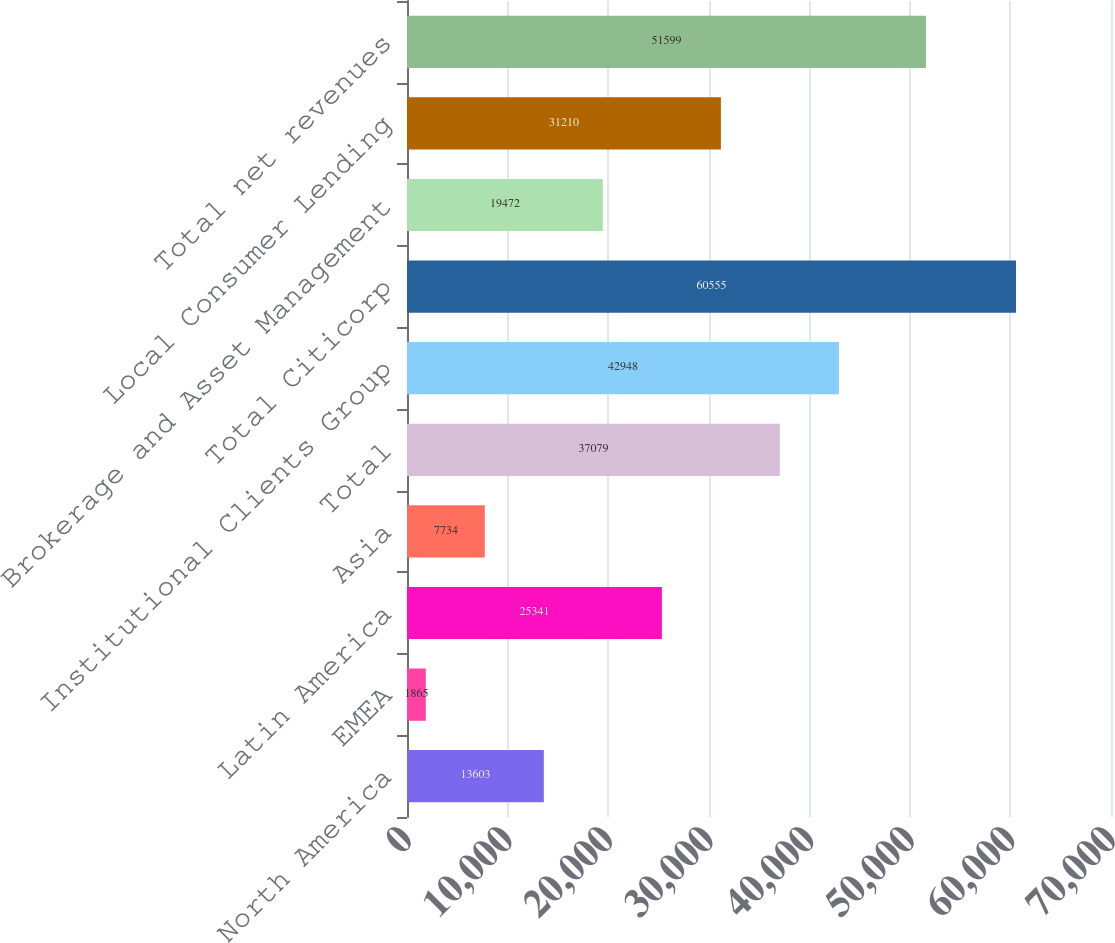<chart> <loc_0><loc_0><loc_500><loc_500><bar_chart><fcel>North America<fcel>EMEA<fcel>Latin America<fcel>Asia<fcel>Total<fcel>Institutional Clients Group<fcel>Total Citicorp<fcel>Brokerage and Asset Management<fcel>Local Consumer Lending<fcel>Total net revenues<nl><fcel>13603<fcel>1865<fcel>25341<fcel>7734<fcel>37079<fcel>42948<fcel>60555<fcel>19472<fcel>31210<fcel>51599<nl></chart> 